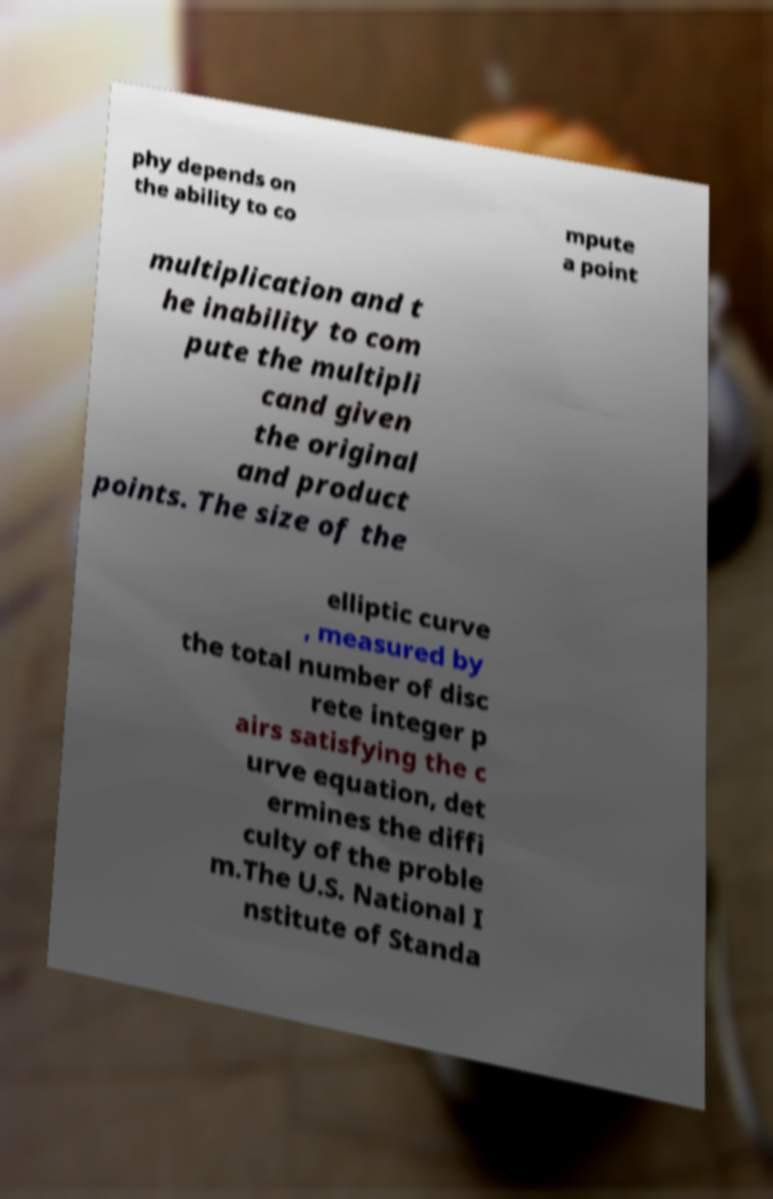Can you accurately transcribe the text from the provided image for me? phy depends on the ability to co mpute a point multiplication and t he inability to com pute the multipli cand given the original and product points. The size of the elliptic curve , measured by the total number of disc rete integer p airs satisfying the c urve equation, det ermines the diffi culty of the proble m.The U.S. National I nstitute of Standa 